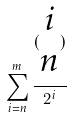Convert formula to latex. <formula><loc_0><loc_0><loc_500><loc_500>\sum _ { i = n } ^ { m } \frac { ( \begin{matrix} i \\ n \end{matrix} ) } { 2 ^ { i } }</formula> 